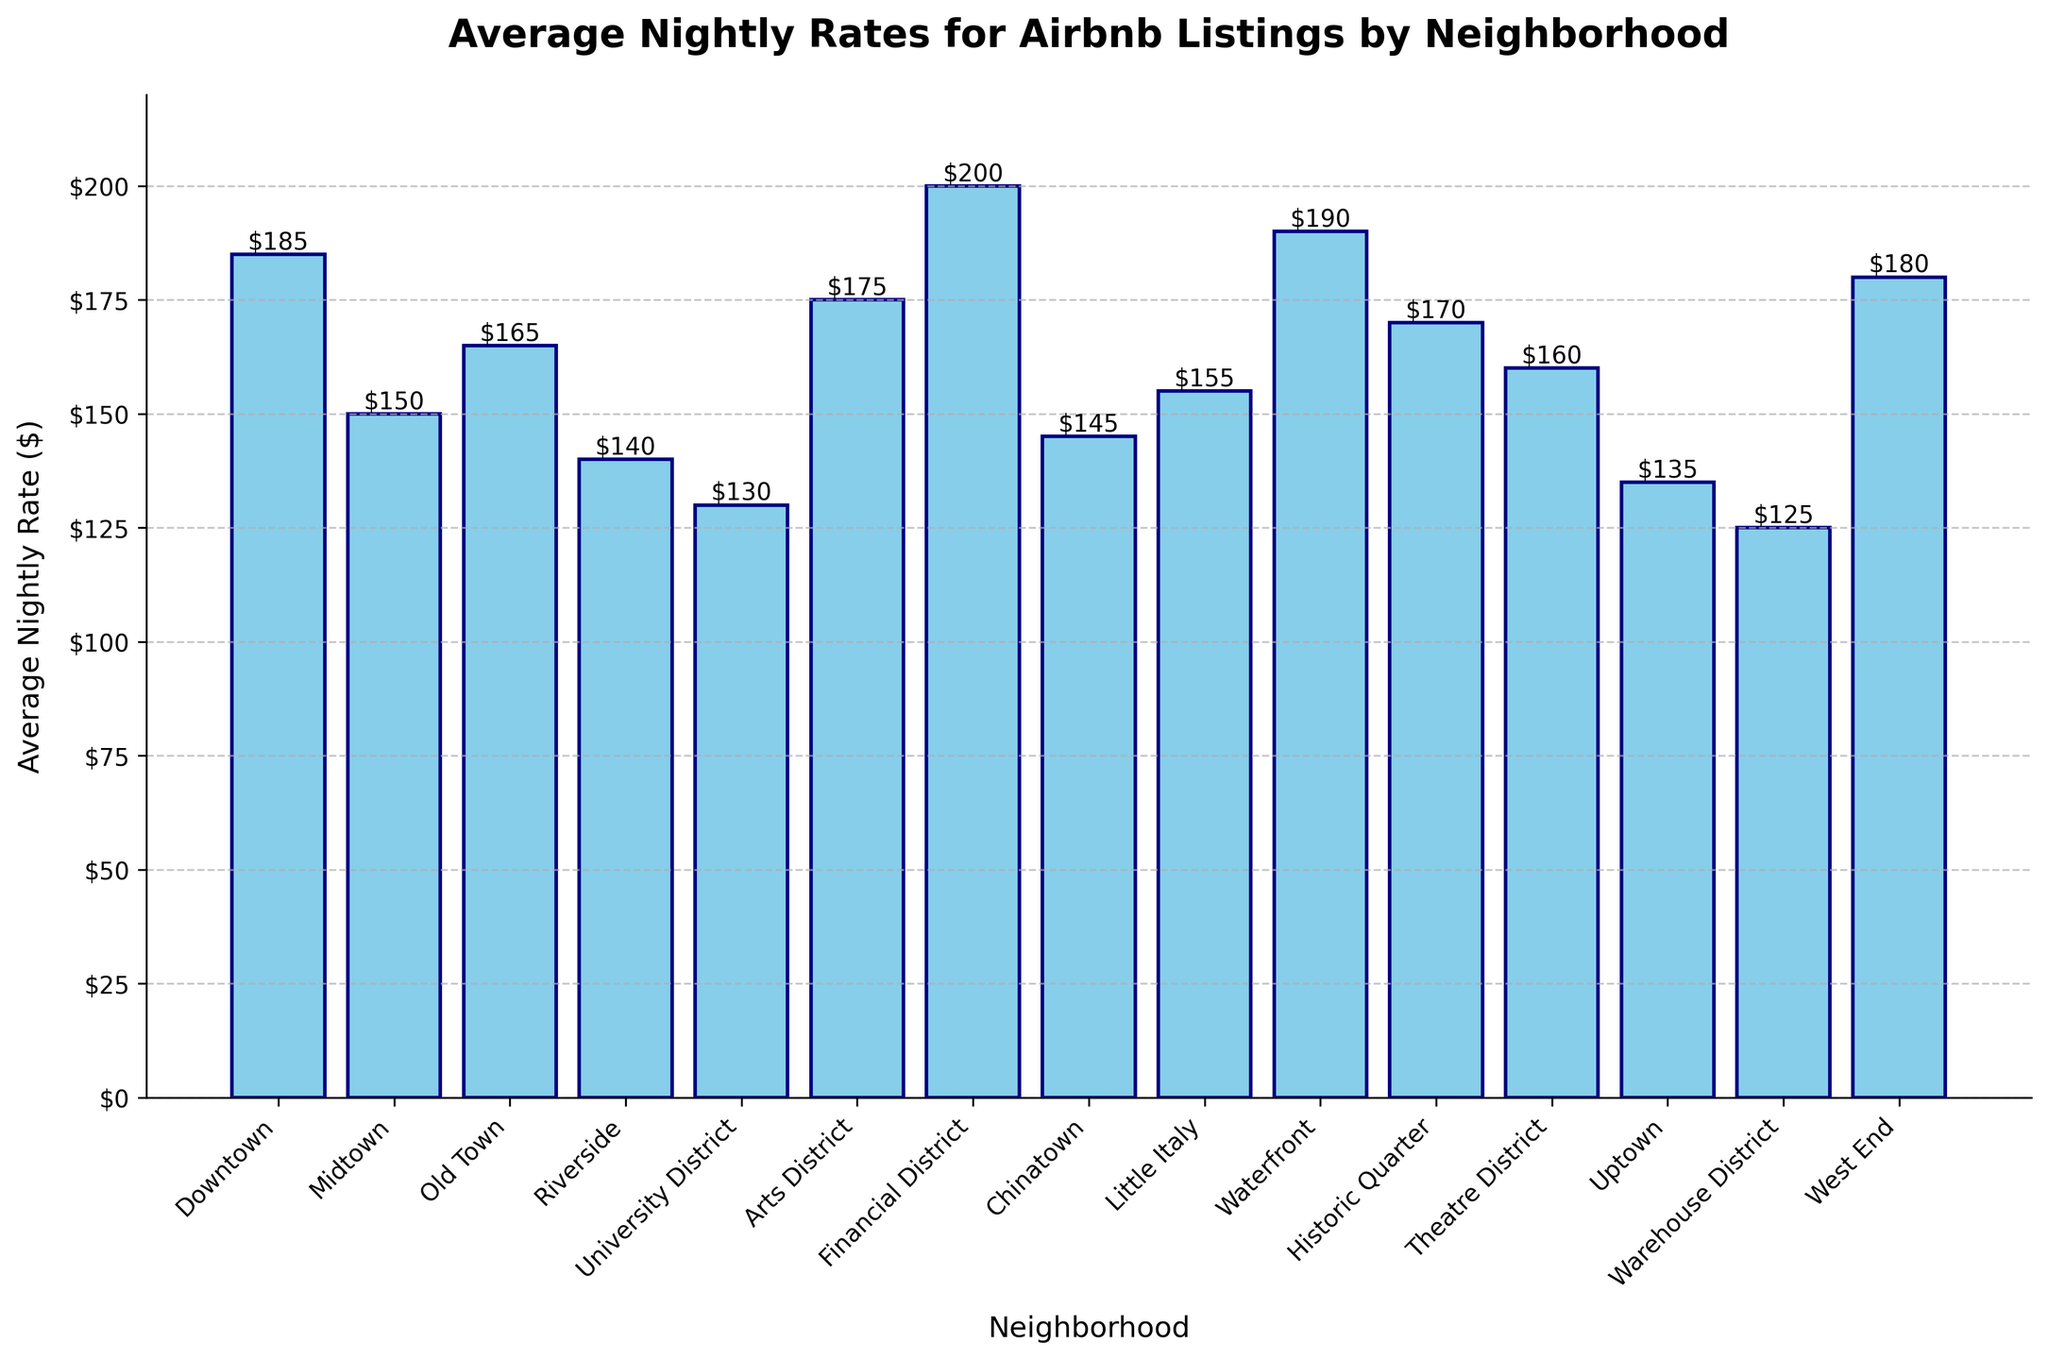Which neighborhood has the highest average nightly rate? To find the neighborhood with the highest average nightly rate, look at the tallest bar in the chart, which represents the Financial District
Answer: Financial District Which neighborhood has the lowest average nightly rate? To find the neighborhood with the lowest average nightly rate, identify the shortest bar in the chart, which represents the Warehouse District
Answer: Warehouse District Which neighborhood has a higher average nightly rate, Midtown or Uptown? Compare the heights of the bars for Midtown and Uptown: Midtown's bar is higher, so Midtown has a higher average nightly rate
Answer: Midtown How does the average nightly rate for Downtown compare to Riverside? Compare the heights of the bars for Downtown and Riverside: Downtown’s bar is taller than Riverside’s, indicating a higher nightly rate for Downtown
Answer: Downtown What is the difference in average nightly rates between the Historic Quarter and the Theatre District? The Historical Quarter has a rate of $170 and the Theatre District has a rate of $160. The difference is found by subtracting: $170 - $160 = $10
Answer: $10 What is the average nightly rate for neighborhoods with rates above $160? Identify neighborhoods with average nightly rates above $160 (Downtown, Financial District, Waterfront, West End, Arts District, Historic Quarter). Sum these rates and divide by the number of neighborhoods: (185 + 200 + 190 + 180 + 175 + 170) / 6 = 1,100 / 6 ≈ $183.33
Answer: ≈ $183.33 Among Chinatown, Little Italy, and Midtown, which has the lowest average nightly rate? Compare the bars for Chinatown ($145), Little Italy ($155), and Midtown ($150). Chinatown’s bar is the shortest, indicating the lowest rate among the three
Answer: Chinatown Between the Arts District and Old Town, which has a higher value and by how much? Arts District has a nightly rate of $175 and Old Town has $165. The difference is $175 - $165 = $10
Answer: Arts District by $10 Which neighborhood has a similar average nightly rate to Old Town? Look for bars that are at a similar height to Old Town's bar (with a value of $165). Historic Quarter is very close with a rate of $170, which is the most similar in height
Answer: Historic Quarter What is the combined average nightly rate of Uptown and University District? Add the rates for Uptown ($135) and University District ($130): $135 + $130 = $265
Answer: $265 